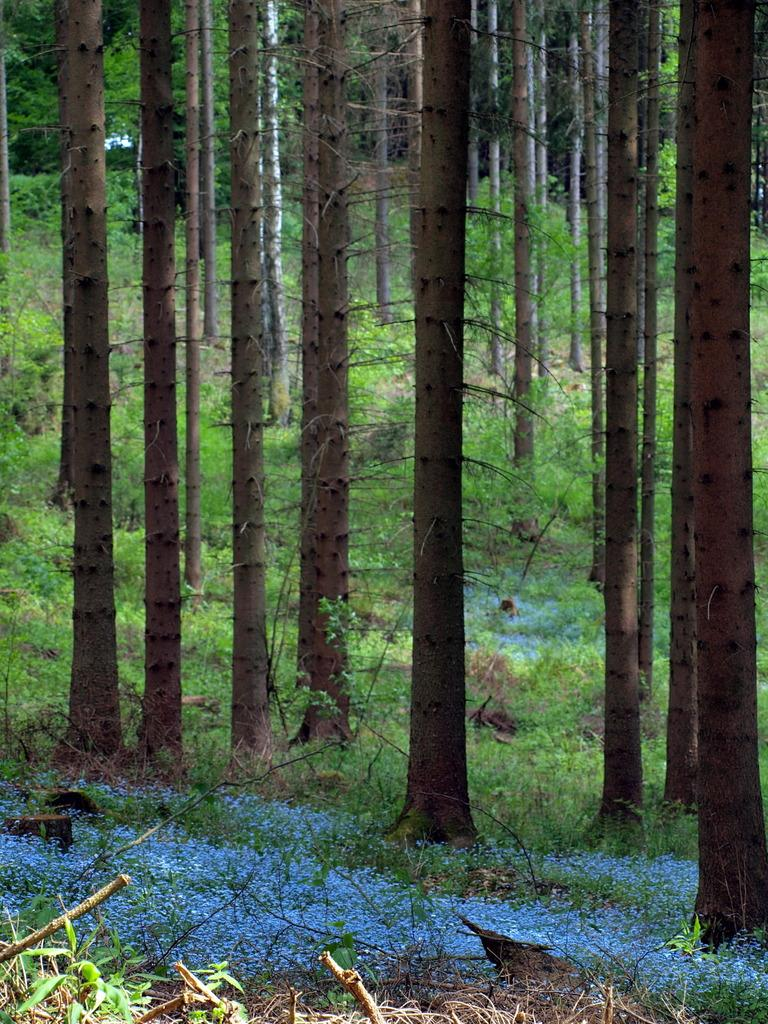Where was the image taken? The image is taken outdoors. What can be seen at the bottom of the image? There is a ground with grass at the bottom of the image. What type of vegetation is present on the ground? There are a few plants on the ground. What can be seen in the background of the image? There are many trees in the background of the image. How does the basketball rub against the brother in the image? There is no basketball or brother present in the image. 